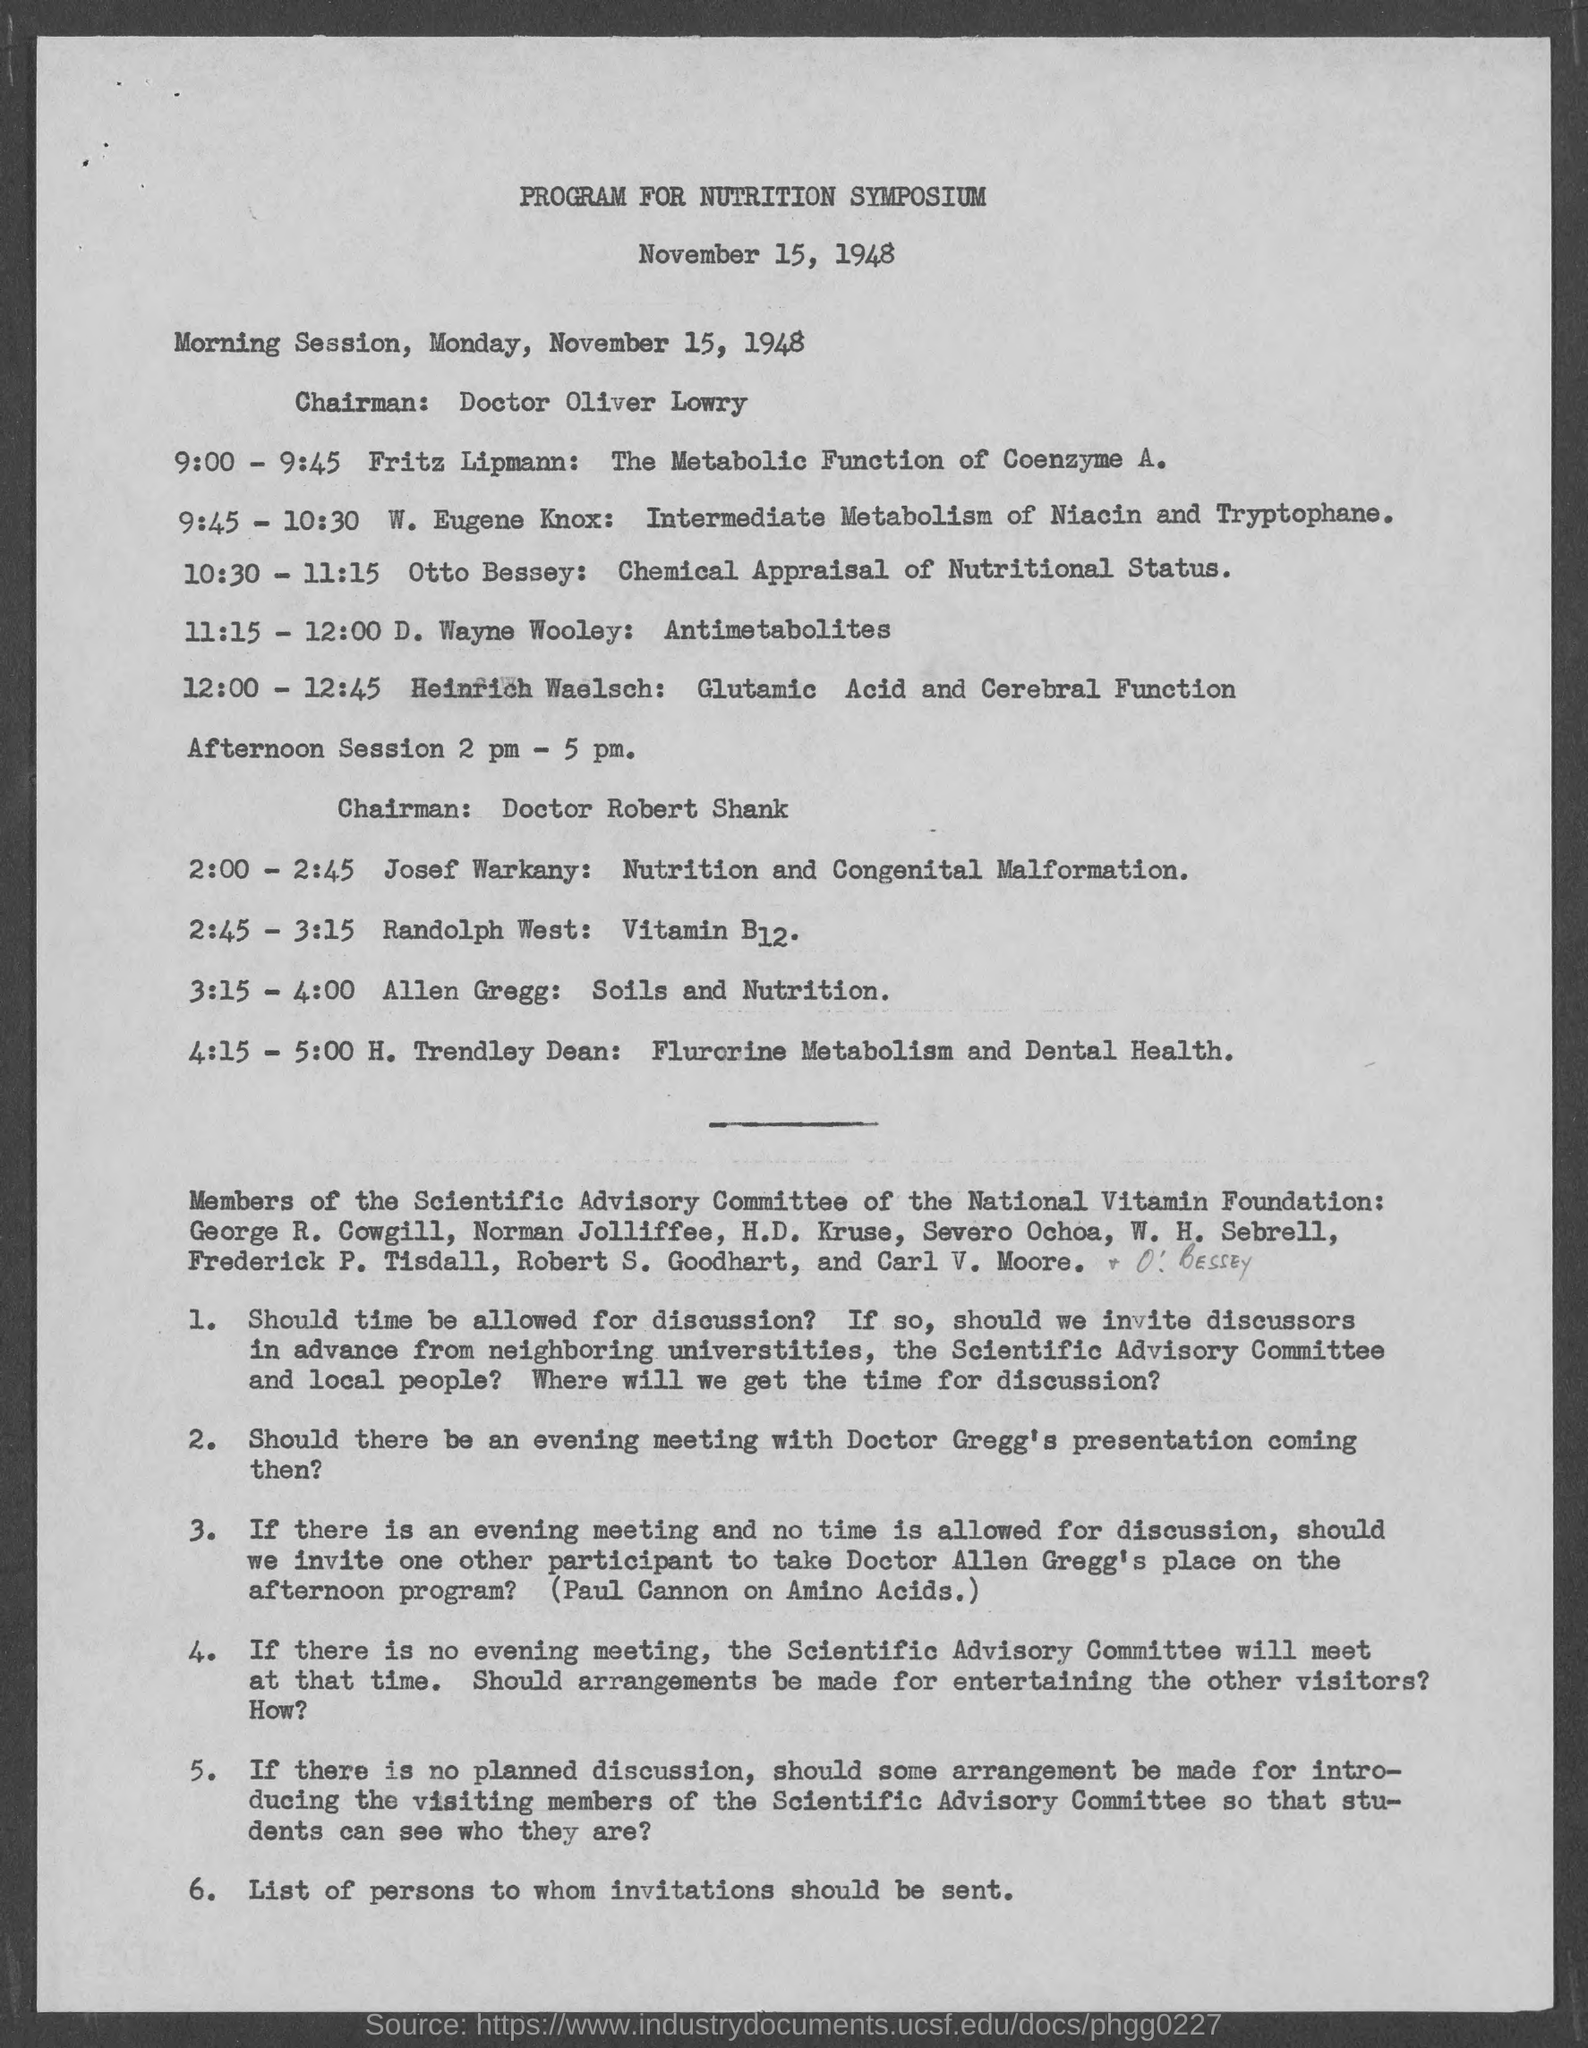Indicate a few pertinent items in this graphic. The Nutrition Symposium will be held on November 15, 1948. The session 'D. Wayne Wooley: Antimetabolites,' which was held on Monday, November 15, 1948, started at 11:15 and ended at 12:00. The chairman for the morning session is Doctor Oliver Lowry. During the afternoon sessions, Doctor Robert Shank served as the chairman. The afternoon sessions are held from 2:00 PM to 5:00 PM. 